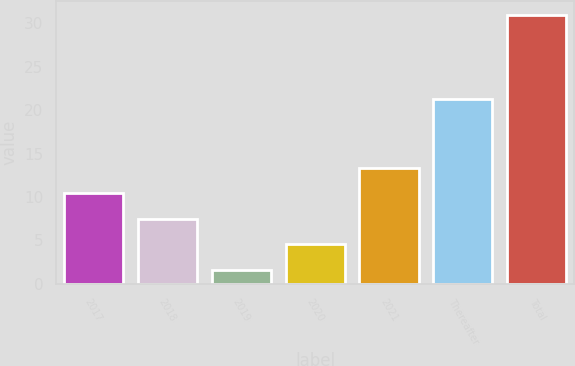Convert chart to OTSL. <chart><loc_0><loc_0><loc_500><loc_500><bar_chart><fcel>2017<fcel>2018<fcel>2019<fcel>2020<fcel>2021<fcel>Thereafter<fcel>Total<nl><fcel>10.42<fcel>7.48<fcel>1.6<fcel>4.54<fcel>13.36<fcel>21.3<fcel>31<nl></chart> 